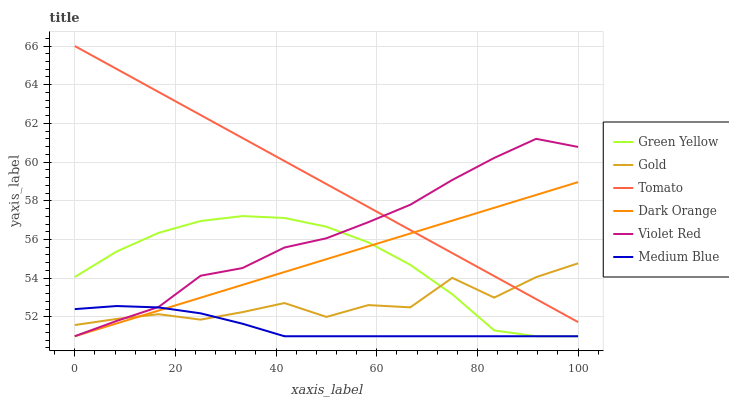Does Medium Blue have the minimum area under the curve?
Answer yes or no. Yes. Does Tomato have the maximum area under the curve?
Answer yes or no. Yes. Does Dark Orange have the minimum area under the curve?
Answer yes or no. No. Does Dark Orange have the maximum area under the curve?
Answer yes or no. No. Is Dark Orange the smoothest?
Answer yes or no. Yes. Is Gold the roughest?
Answer yes or no. Yes. Is Violet Red the smoothest?
Answer yes or no. No. Is Violet Red the roughest?
Answer yes or no. No. Does Dark Orange have the lowest value?
Answer yes or no. Yes. Does Gold have the lowest value?
Answer yes or no. No. Does Tomato have the highest value?
Answer yes or no. Yes. Does Dark Orange have the highest value?
Answer yes or no. No. Is Medium Blue less than Tomato?
Answer yes or no. Yes. Is Tomato greater than Green Yellow?
Answer yes or no. Yes. Does Violet Red intersect Green Yellow?
Answer yes or no. Yes. Is Violet Red less than Green Yellow?
Answer yes or no. No. Is Violet Red greater than Green Yellow?
Answer yes or no. No. Does Medium Blue intersect Tomato?
Answer yes or no. No. 